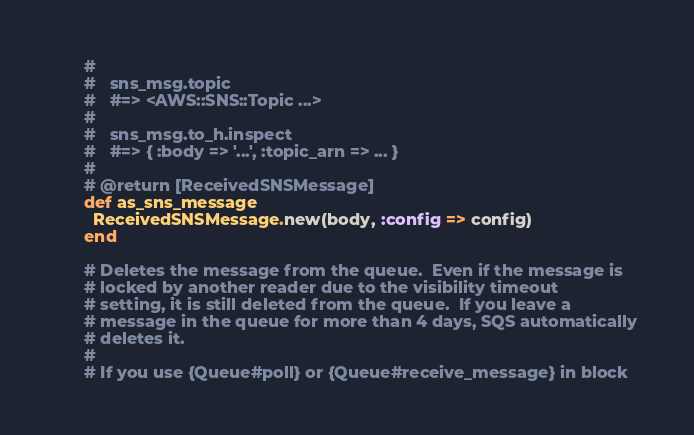Convert code to text. <code><loc_0><loc_0><loc_500><loc_500><_Ruby_>      # 
      #   sns_msg.topic
      #   #=> <AWS::SNS::Topic ...>
      #
      #   sns_msg.to_h.inspect
      #   #=> { :body => '...', :topic_arn => ... }
      #
      # @return [ReceivedSNSMessage]
      def as_sns_message
        ReceivedSNSMessage.new(body, :config => config)
      end

      # Deletes the message from the queue.  Even if the message is
      # locked by another reader due to the visibility timeout
      # setting, it is still deleted from the queue.  If you leave a
      # message in the queue for more than 4 days, SQS automatically
      # deletes it.
      #
      # If you use {Queue#poll} or {Queue#receive_message} in block</code> 